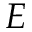Convert formula to latex. <formula><loc_0><loc_0><loc_500><loc_500>E</formula> 